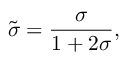Convert formula to latex. <formula><loc_0><loc_0><loc_500><loc_500>\tilde { \sigma } = { \frac { \sigma } { 1 + 2 \sigma } } ,</formula> 